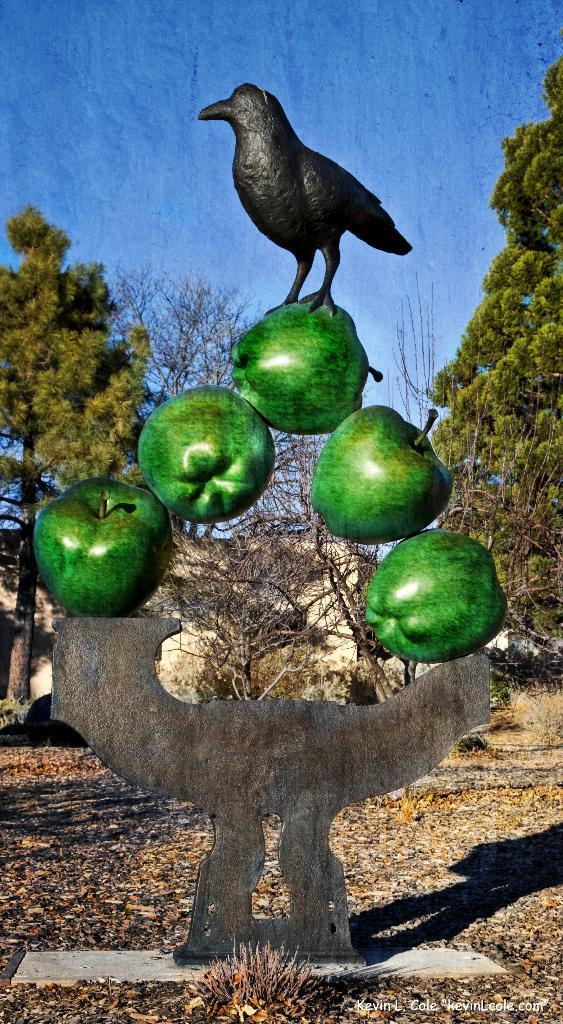What is the main subject in the image? There is a sculpture in the image. What can be seen in the background of the image? There are trees, a building, and the sky visible in the background of the image. How many babies are holding a crown in the image? There are no babies or crowns present in the image. 